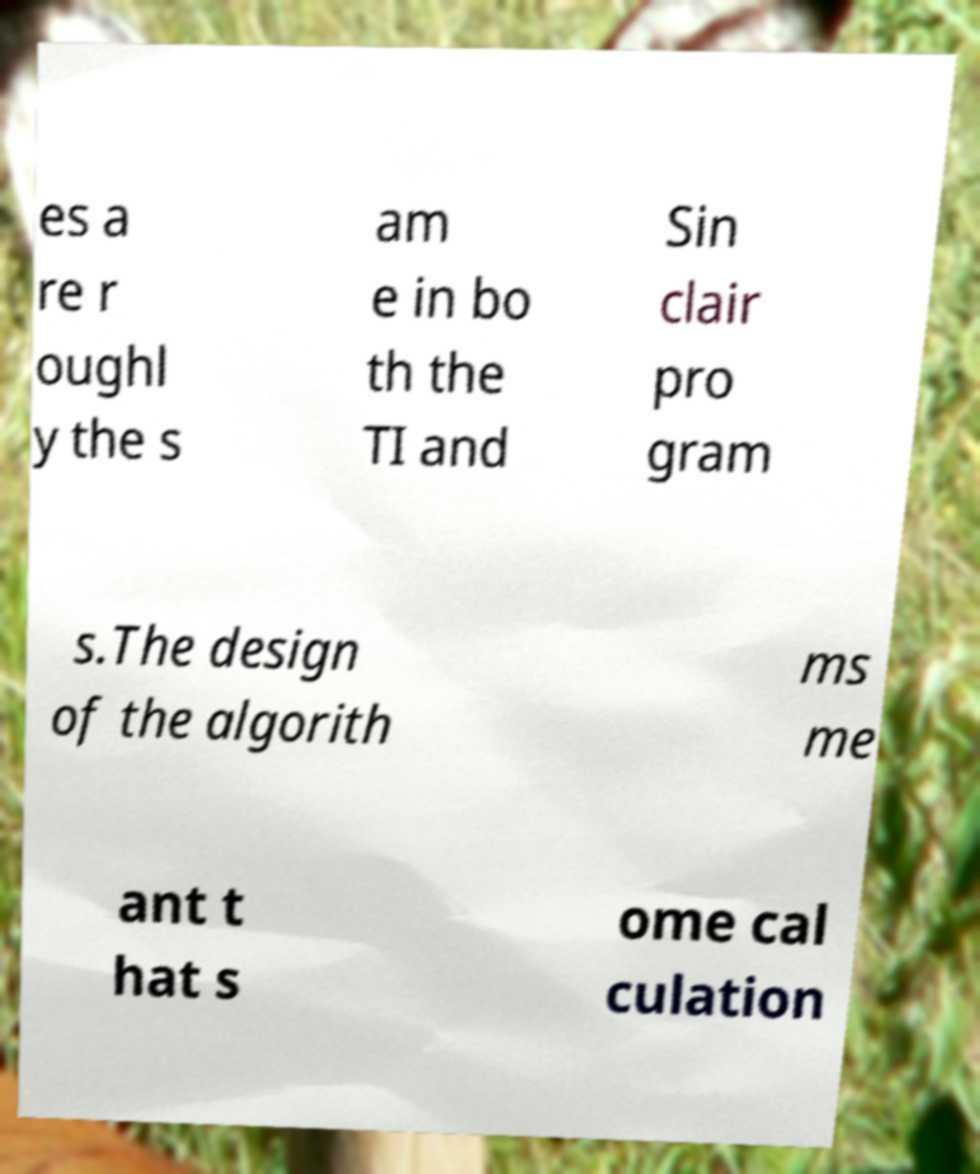Please read and relay the text visible in this image. What does it say? es a re r oughl y the s am e in bo th the TI and Sin clair pro gram s.The design of the algorith ms me ant t hat s ome cal culation 